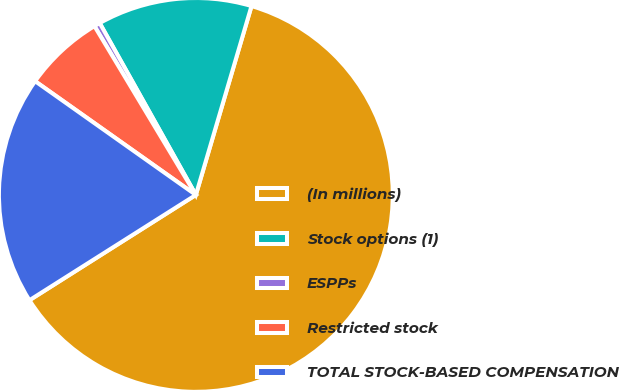Convert chart. <chart><loc_0><loc_0><loc_500><loc_500><pie_chart><fcel>(In millions)<fcel>Stock options (1)<fcel>ESPPs<fcel>Restricted stock<fcel>TOTAL STOCK-BASED COMPENSATION<nl><fcel>61.46%<fcel>12.68%<fcel>0.49%<fcel>6.59%<fcel>18.78%<nl></chart> 